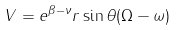Convert formula to latex. <formula><loc_0><loc_0><loc_500><loc_500>V = e ^ { \beta - \nu } r \sin \theta ( \Omega - \omega )</formula> 